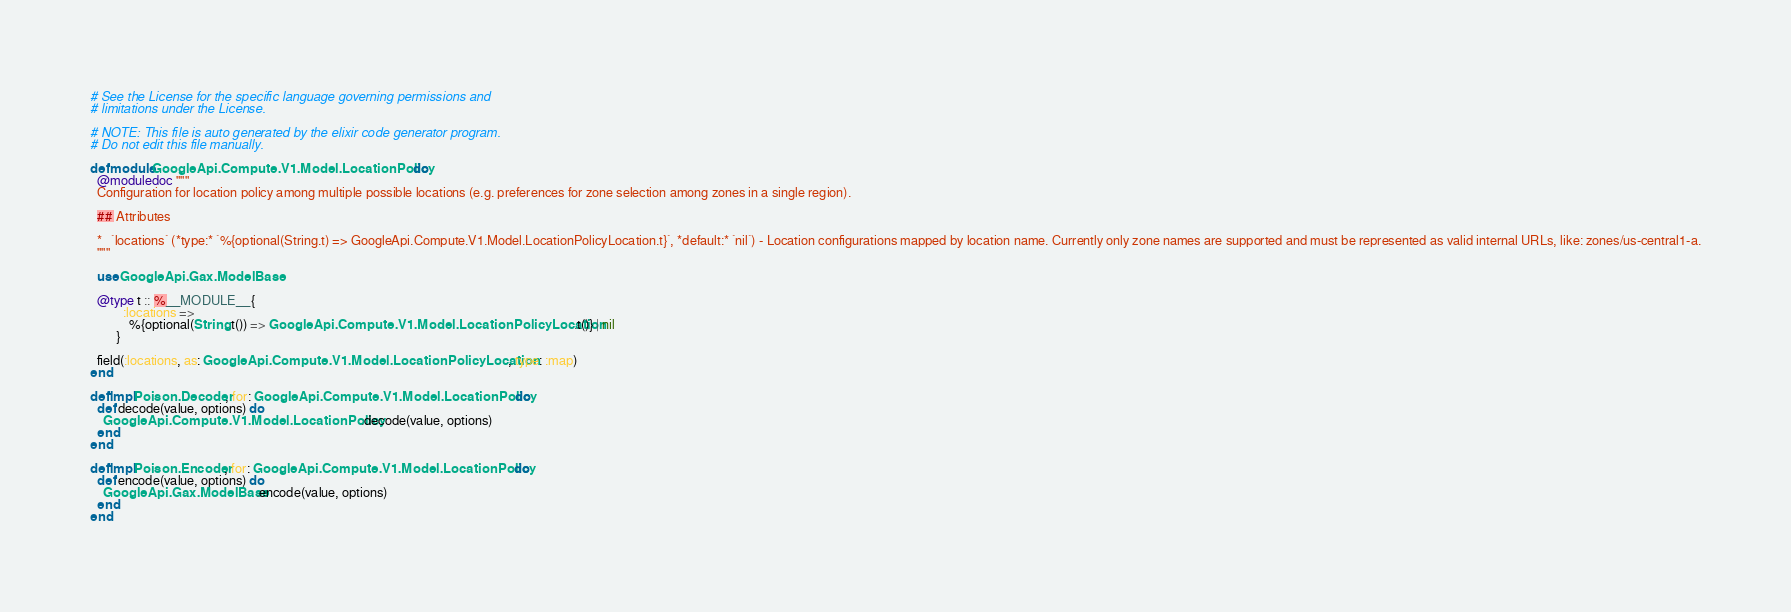Convert code to text. <code><loc_0><loc_0><loc_500><loc_500><_Elixir_># See the License for the specific language governing permissions and
# limitations under the License.

# NOTE: This file is auto generated by the elixir code generator program.
# Do not edit this file manually.

defmodule GoogleApi.Compute.V1.Model.LocationPolicy do
  @moduledoc """
  Configuration for location policy among multiple possible locations (e.g. preferences for zone selection among zones in a single region).

  ## Attributes

  *   `locations` (*type:* `%{optional(String.t) => GoogleApi.Compute.V1.Model.LocationPolicyLocation.t}`, *default:* `nil`) - Location configurations mapped by location name. Currently only zone names are supported and must be represented as valid internal URLs, like: zones/us-central1-a.
  """

  use GoogleApi.Gax.ModelBase

  @type t :: %__MODULE__{
          :locations =>
            %{optional(String.t()) => GoogleApi.Compute.V1.Model.LocationPolicyLocation.t()} | nil
        }

  field(:locations, as: GoogleApi.Compute.V1.Model.LocationPolicyLocation, type: :map)
end

defimpl Poison.Decoder, for: GoogleApi.Compute.V1.Model.LocationPolicy do
  def decode(value, options) do
    GoogleApi.Compute.V1.Model.LocationPolicy.decode(value, options)
  end
end

defimpl Poison.Encoder, for: GoogleApi.Compute.V1.Model.LocationPolicy do
  def encode(value, options) do
    GoogleApi.Gax.ModelBase.encode(value, options)
  end
end
</code> 